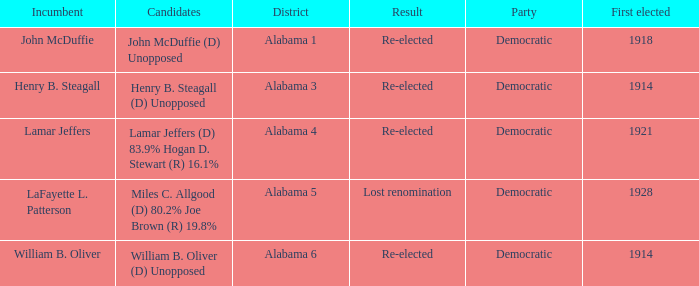How many in lost renomination results were elected first? 1928.0. 